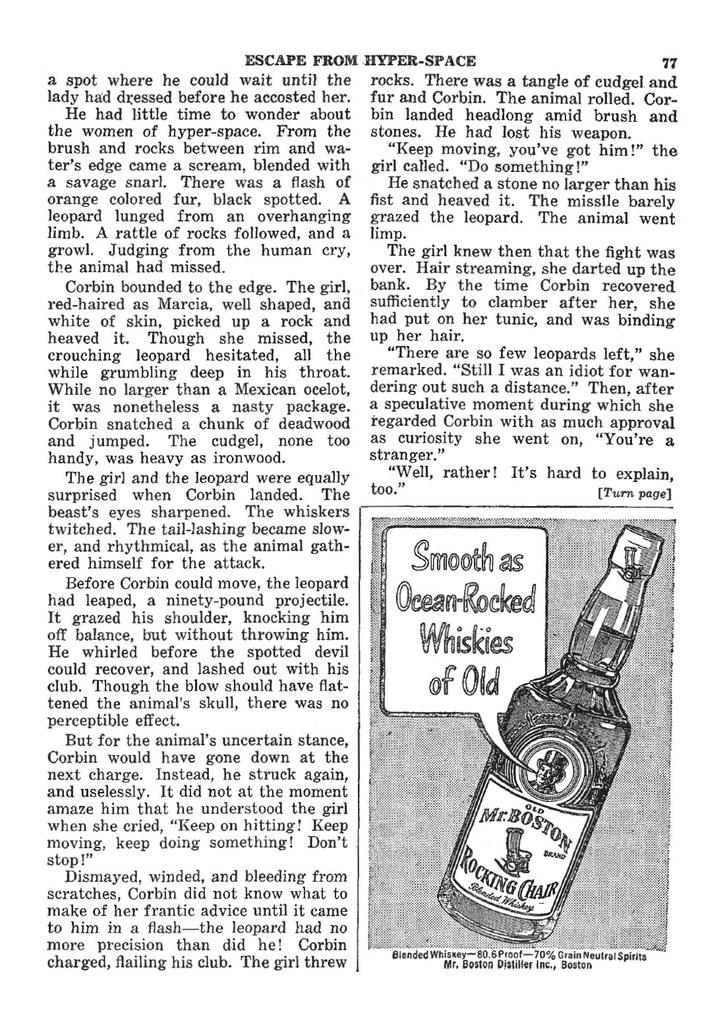<image>
Relay a brief, clear account of the picture shown. Black and white escape from Hyper Space page 77. 